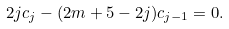Convert formula to latex. <formula><loc_0><loc_0><loc_500><loc_500>2 j c _ { j } - ( 2 m + 5 - 2 j ) c _ { j - 1 } = 0 .</formula> 